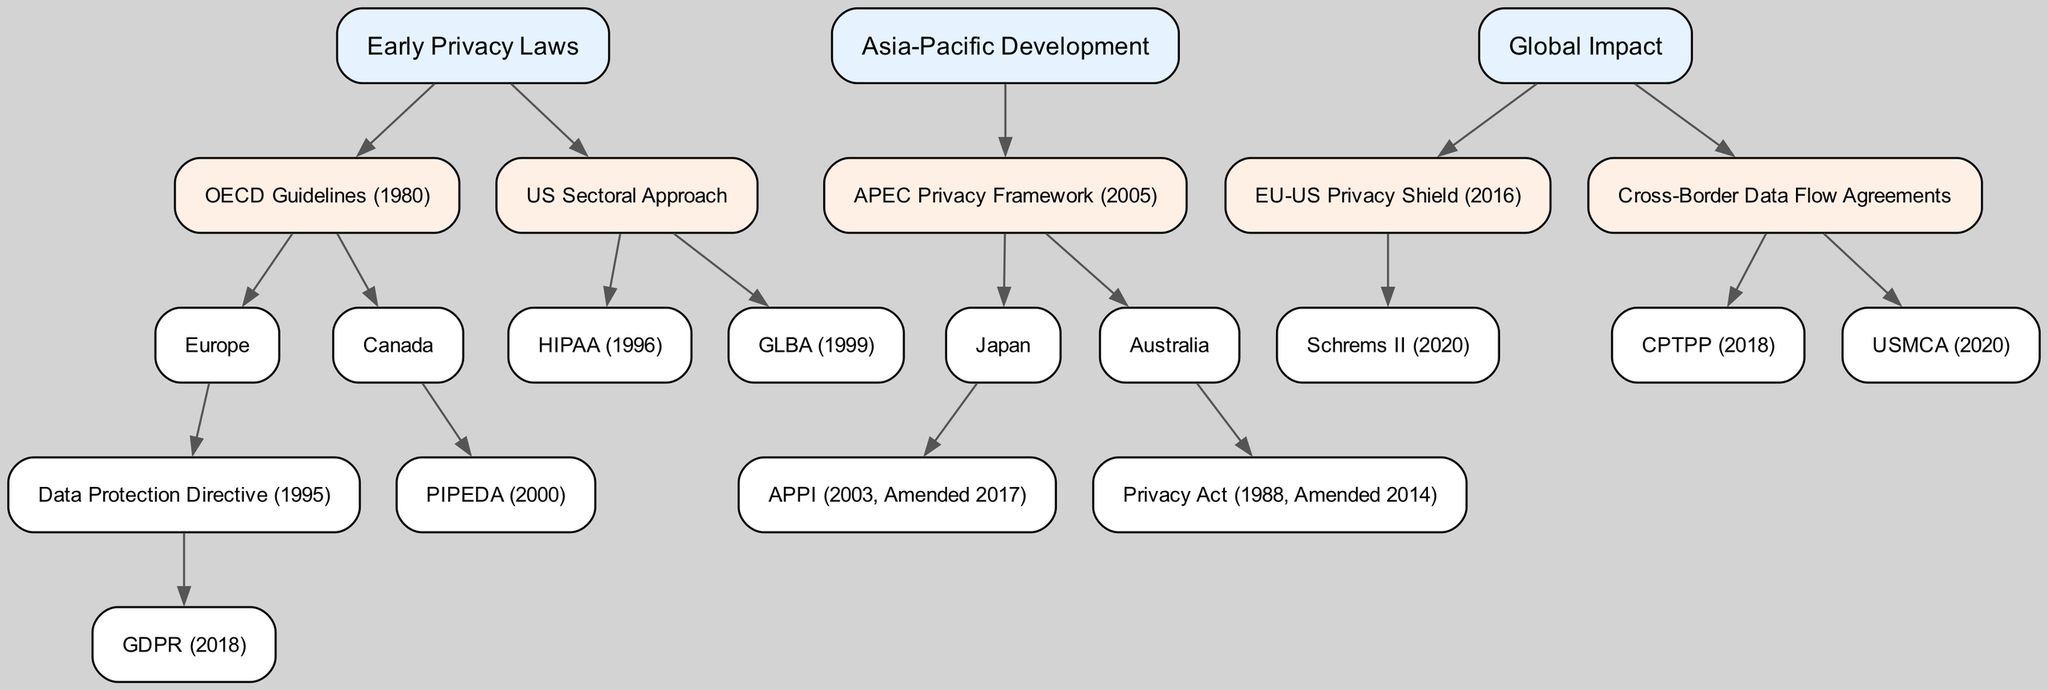What is the first privacy law mentioned in the diagram? The first privacy law listed in the diagram is under the "Early Privacy Laws" section, specifically "OECD Guidelines (1980)".
Answer: OECD Guidelines (1980) Which continent is associated with the Data Protection Directive? The Data Protection Directive is linked to Europe as it's a child node under "Europe" in the "OECD Guidelines (1980)" section.
Answer: Europe How many main branches are there in the "Global Impact" section? The "Global Impact" section consists of two main branches, namely "EU-US Privacy Shield (2016)" and "Cross-Border Data Flow Agreements".
Answer: 2 What year was the GDPR established? The GDPR is established in 2018, as indicated under the "Data Protection Directive (1995)" in the diagram.
Answer: 2018 What privacy law was established in Canada? The privacy law established in Canada, as shown in the "Early Privacy Laws" section, is "PIPEDA (2000)".
Answer: PIPEDA (2000) Which law was amended in Japan in 2017? The law that was amended in Japan in 2017 is "APPI (2003, Amended 2017)". This is visible as the child node in the "Japan" section under "APEC Privacy Framework (2005)".
Answer: APPI (2003, Amended 2017) How are the "Cross-Border Data Flow Agreements" related to international trade agreements? "Cross-Border Data Flow Agreements" include trade agreements like CPTPP (2018) and USMCA (2020), which indicates their connection to international trade by facilitating data exchange.
Answer: Trade agreements What triggered the "Schrems II" case in 2020? The "Schrems II" case in 2020 arose in the context of the "EU-US Privacy Shield (2016)" linked to the global impact on cross-border data transfers, reflecting legal challenges around data privacy.
Answer: Legal challenges How does the US sectoral approach differ from comprehensive laws in Europe? The US sectoral approach, which includes laws like HIPAA and GLBA, offers specific regulations rather than a comprehensive legal framework, contrasting with Europe’s overarching GDPR.
Answer: Specific regulations 